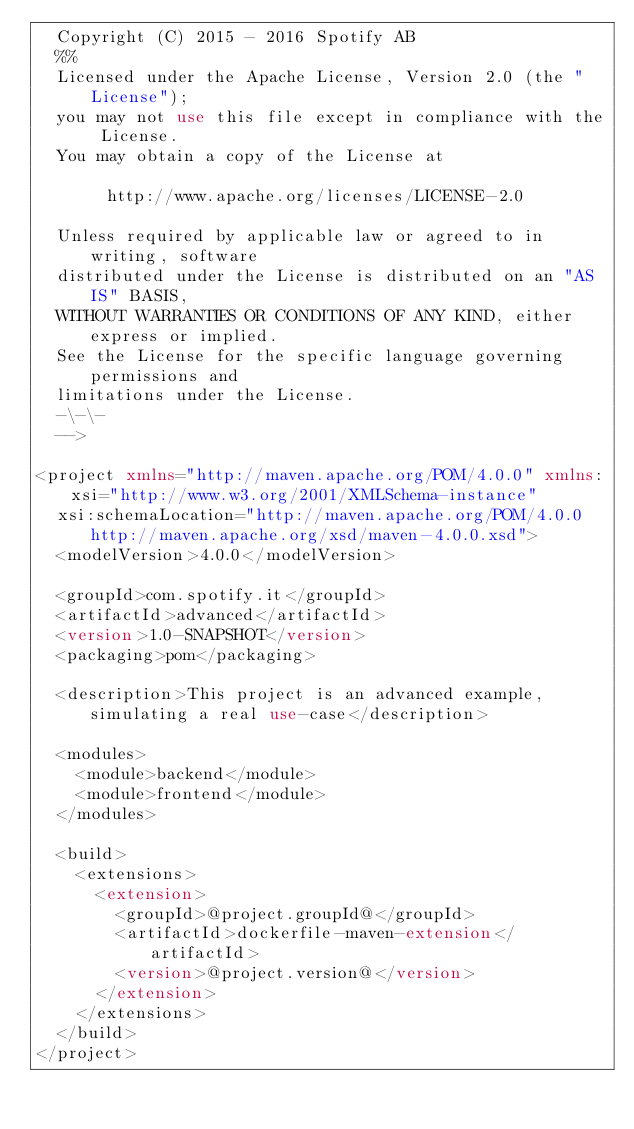Convert code to text. <code><loc_0><loc_0><loc_500><loc_500><_XML_>  Copyright (C) 2015 - 2016 Spotify AB
  %%
  Licensed under the Apache License, Version 2.0 (the "License");
  you may not use this file except in compliance with the License.
  You may obtain a copy of the License at
  
       http://www.apache.org/licenses/LICENSE-2.0
  
  Unless required by applicable law or agreed to in writing, software
  distributed under the License is distributed on an "AS IS" BASIS,
  WITHOUT WARRANTIES OR CONDITIONS OF ANY KIND, either express or implied.
  See the License for the specific language governing permissions and
  limitations under the License.
  -\-\-
  -->

<project xmlns="http://maven.apache.org/POM/4.0.0" xmlns:xsi="http://www.w3.org/2001/XMLSchema-instance"
  xsi:schemaLocation="http://maven.apache.org/POM/4.0.0 http://maven.apache.org/xsd/maven-4.0.0.xsd">
  <modelVersion>4.0.0</modelVersion>

  <groupId>com.spotify.it</groupId>
  <artifactId>advanced</artifactId>
  <version>1.0-SNAPSHOT</version>
  <packaging>pom</packaging>

  <description>This project is an advanced example, simulating a real use-case</description>

  <modules>
    <module>backend</module>
    <module>frontend</module>
  </modules>

  <build>
    <extensions>
      <extension>
        <groupId>@project.groupId@</groupId>
        <artifactId>dockerfile-maven-extension</artifactId>
        <version>@project.version@</version>
      </extension>
    </extensions>
  </build>
</project>
</code> 